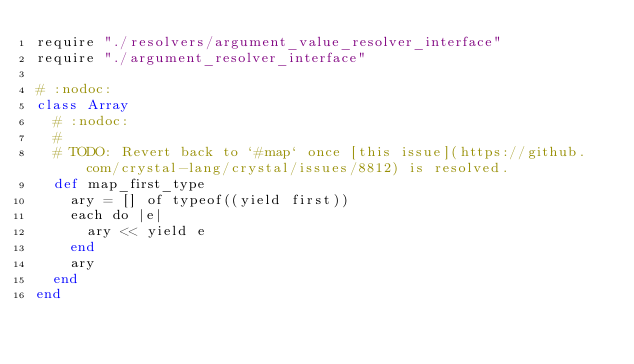<code> <loc_0><loc_0><loc_500><loc_500><_Crystal_>require "./resolvers/argument_value_resolver_interface"
require "./argument_resolver_interface"

# :nodoc:
class Array
  # :nodoc:
  #
  # TODO: Revert back to `#map` once [this issue](https://github.com/crystal-lang/crystal/issues/8812) is resolved.
  def map_first_type
    ary = [] of typeof((yield first))
    each do |e|
      ary << yield e
    end
    ary
  end
end
</code> 